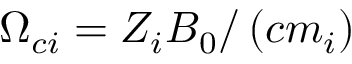<formula> <loc_0><loc_0><loc_500><loc_500>\Omega _ { c i } = Z _ { i } B _ { 0 } / \left ( c m _ { i } \right )</formula> 